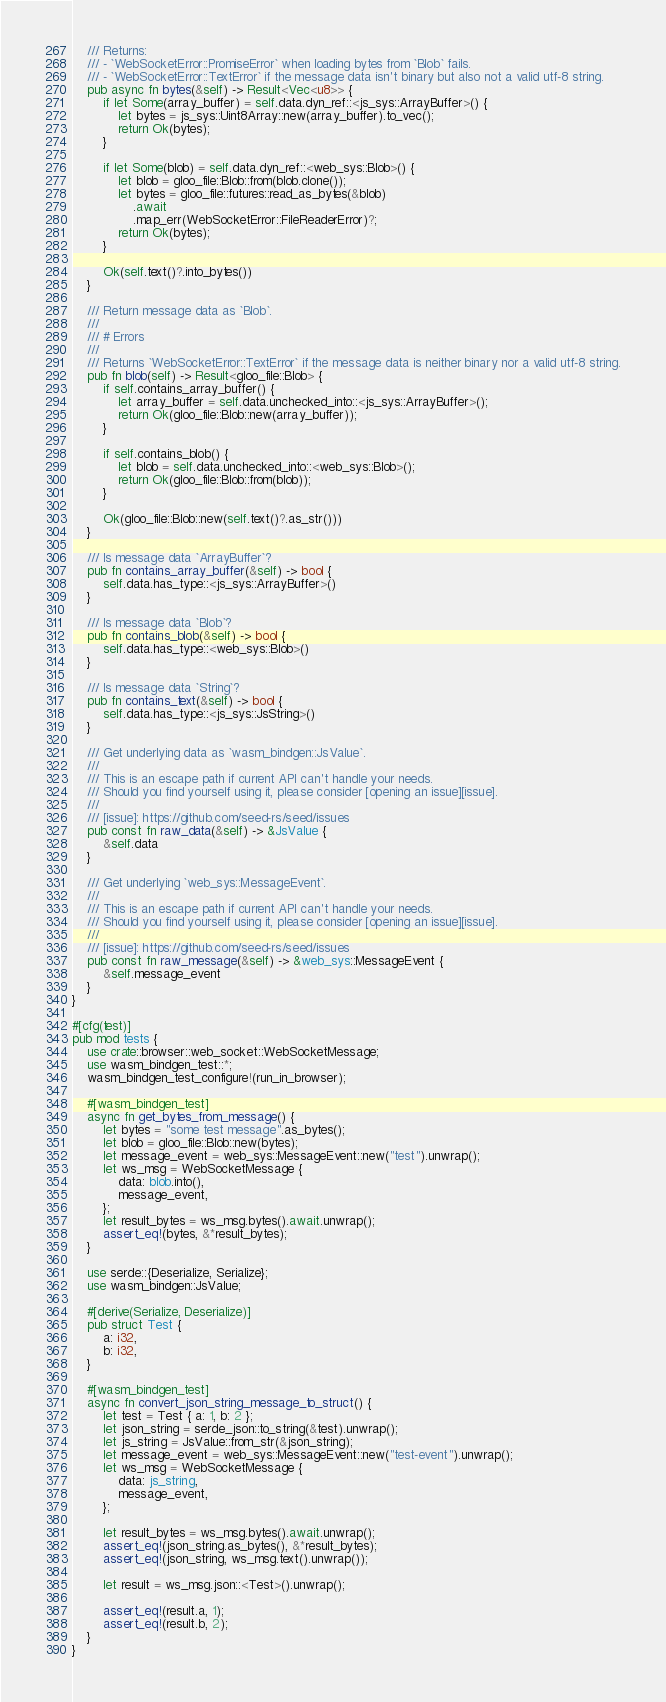<code> <loc_0><loc_0><loc_500><loc_500><_Rust_>    /// Returns:
    /// - `WebSocketError::PromiseError` when loading bytes from `Blob` fails.
    /// - `WebSocketError::TextError` if the message data isn't binary but also not a valid utf-8 string.
    pub async fn bytes(&self) -> Result<Vec<u8>> {
        if let Some(array_buffer) = self.data.dyn_ref::<js_sys::ArrayBuffer>() {
            let bytes = js_sys::Uint8Array::new(array_buffer).to_vec();
            return Ok(bytes);
        }

        if let Some(blob) = self.data.dyn_ref::<web_sys::Blob>() {
            let blob = gloo_file::Blob::from(blob.clone());
            let bytes = gloo_file::futures::read_as_bytes(&blob)
                .await
                .map_err(WebSocketError::FileReaderError)?;
            return Ok(bytes);
        }

        Ok(self.text()?.into_bytes())
    }

    /// Return message data as `Blob`.
    ///
    /// # Errors
    ///
    /// Returns `WebSocketError::TextError` if the message data is neither binary nor a valid utf-8 string.
    pub fn blob(self) -> Result<gloo_file::Blob> {
        if self.contains_array_buffer() {
            let array_buffer = self.data.unchecked_into::<js_sys::ArrayBuffer>();
            return Ok(gloo_file::Blob::new(array_buffer));
        }

        if self.contains_blob() {
            let blob = self.data.unchecked_into::<web_sys::Blob>();
            return Ok(gloo_file::Blob::from(blob));
        }

        Ok(gloo_file::Blob::new(self.text()?.as_str()))
    }

    /// Is message data `ArrayBuffer`?
    pub fn contains_array_buffer(&self) -> bool {
        self.data.has_type::<js_sys::ArrayBuffer>()
    }

    /// Is message data `Blob`?
    pub fn contains_blob(&self) -> bool {
        self.data.has_type::<web_sys::Blob>()
    }

    /// Is message data `String`?
    pub fn contains_text(&self) -> bool {
        self.data.has_type::<js_sys::JsString>()
    }

    /// Get underlying data as `wasm_bindgen::JsValue`.
    ///
    /// This is an escape path if current API can't handle your needs.
    /// Should you find yourself using it, please consider [opening an issue][issue].
    ///
    /// [issue]: https://github.com/seed-rs/seed/issues
    pub const fn raw_data(&self) -> &JsValue {
        &self.data
    }

    /// Get underlying `web_sys::MessageEvent`.
    ///
    /// This is an escape path if current API can't handle your needs.
    /// Should you find yourself using it, please consider [opening an issue][issue].
    ///
    /// [issue]: https://github.com/seed-rs/seed/issues
    pub const fn raw_message(&self) -> &web_sys::MessageEvent {
        &self.message_event
    }
}

#[cfg(test)]
pub mod tests {
    use crate::browser::web_socket::WebSocketMessage;
    use wasm_bindgen_test::*;
    wasm_bindgen_test_configure!(run_in_browser);

    #[wasm_bindgen_test]
    async fn get_bytes_from_message() {
        let bytes = "some test message".as_bytes();
        let blob = gloo_file::Blob::new(bytes);
        let message_event = web_sys::MessageEvent::new("test").unwrap();
        let ws_msg = WebSocketMessage {
            data: blob.into(),
            message_event,
        };
        let result_bytes = ws_msg.bytes().await.unwrap();
        assert_eq!(bytes, &*result_bytes);
    }

    use serde::{Deserialize, Serialize};
    use wasm_bindgen::JsValue;

    #[derive(Serialize, Deserialize)]
    pub struct Test {
        a: i32,
        b: i32,
    }

    #[wasm_bindgen_test]
    async fn convert_json_string_message_to_struct() {
        let test = Test { a: 1, b: 2 };
        let json_string = serde_json::to_string(&test).unwrap();
        let js_string = JsValue::from_str(&json_string);
        let message_event = web_sys::MessageEvent::new("test-event").unwrap();
        let ws_msg = WebSocketMessage {
            data: js_string,
            message_event,
        };

        let result_bytes = ws_msg.bytes().await.unwrap();
        assert_eq!(json_string.as_bytes(), &*result_bytes);
        assert_eq!(json_string, ws_msg.text().unwrap());

        let result = ws_msg.json::<Test>().unwrap();

        assert_eq!(result.a, 1);
        assert_eq!(result.b, 2);
    }
}
</code> 